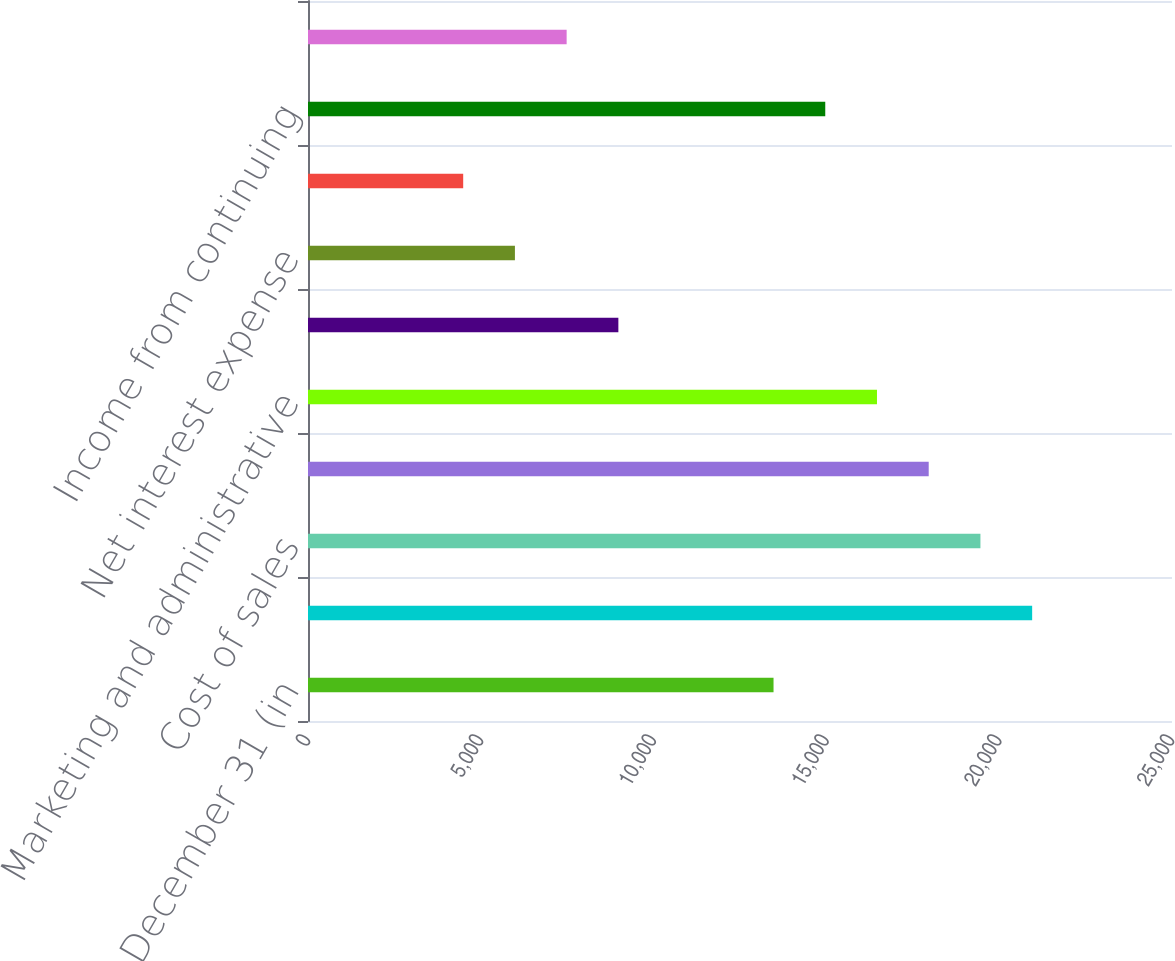Convert chart to OTSL. <chart><loc_0><loc_0><loc_500><loc_500><bar_chart><fcel>years ended December 31 (in<fcel>Net sales<fcel>Cost of sales<fcel>Gross margin<fcel>Marketing and administrative<fcel>Research and development<fcel>Net interest expense<fcel>Other expense (income) net<fcel>Income from continuing<fcel>Income tax expense<nl><fcel>13470.4<fcel>20953.6<fcel>19457<fcel>17960.3<fcel>16463.7<fcel>8980.48<fcel>5987.2<fcel>4490.56<fcel>14967<fcel>7483.84<nl></chart> 